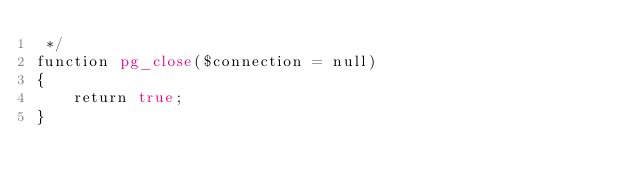<code> <loc_0><loc_0><loc_500><loc_500><_PHP_> */
function pg_close($connection = null)
{
    return true;
}
</code> 